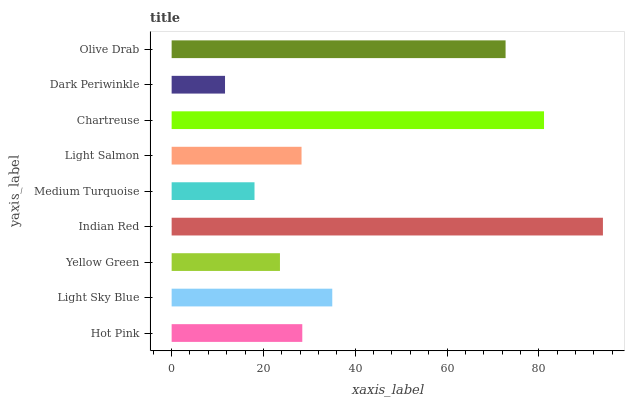Is Dark Periwinkle the minimum?
Answer yes or no. Yes. Is Indian Red the maximum?
Answer yes or no. Yes. Is Light Sky Blue the minimum?
Answer yes or no. No. Is Light Sky Blue the maximum?
Answer yes or no. No. Is Light Sky Blue greater than Hot Pink?
Answer yes or no. Yes. Is Hot Pink less than Light Sky Blue?
Answer yes or no. Yes. Is Hot Pink greater than Light Sky Blue?
Answer yes or no. No. Is Light Sky Blue less than Hot Pink?
Answer yes or no. No. Is Hot Pink the high median?
Answer yes or no. Yes. Is Hot Pink the low median?
Answer yes or no. Yes. Is Light Salmon the high median?
Answer yes or no. No. Is Dark Periwinkle the low median?
Answer yes or no. No. 